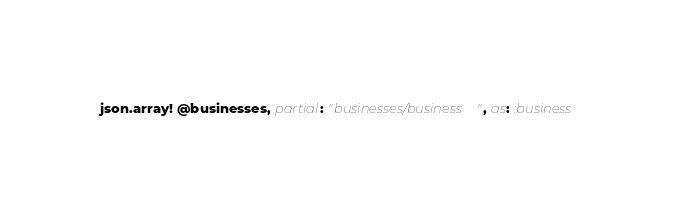<code> <loc_0><loc_0><loc_500><loc_500><_Ruby_>json.array! @businesses, partial: "businesses/business", as: :business
</code> 